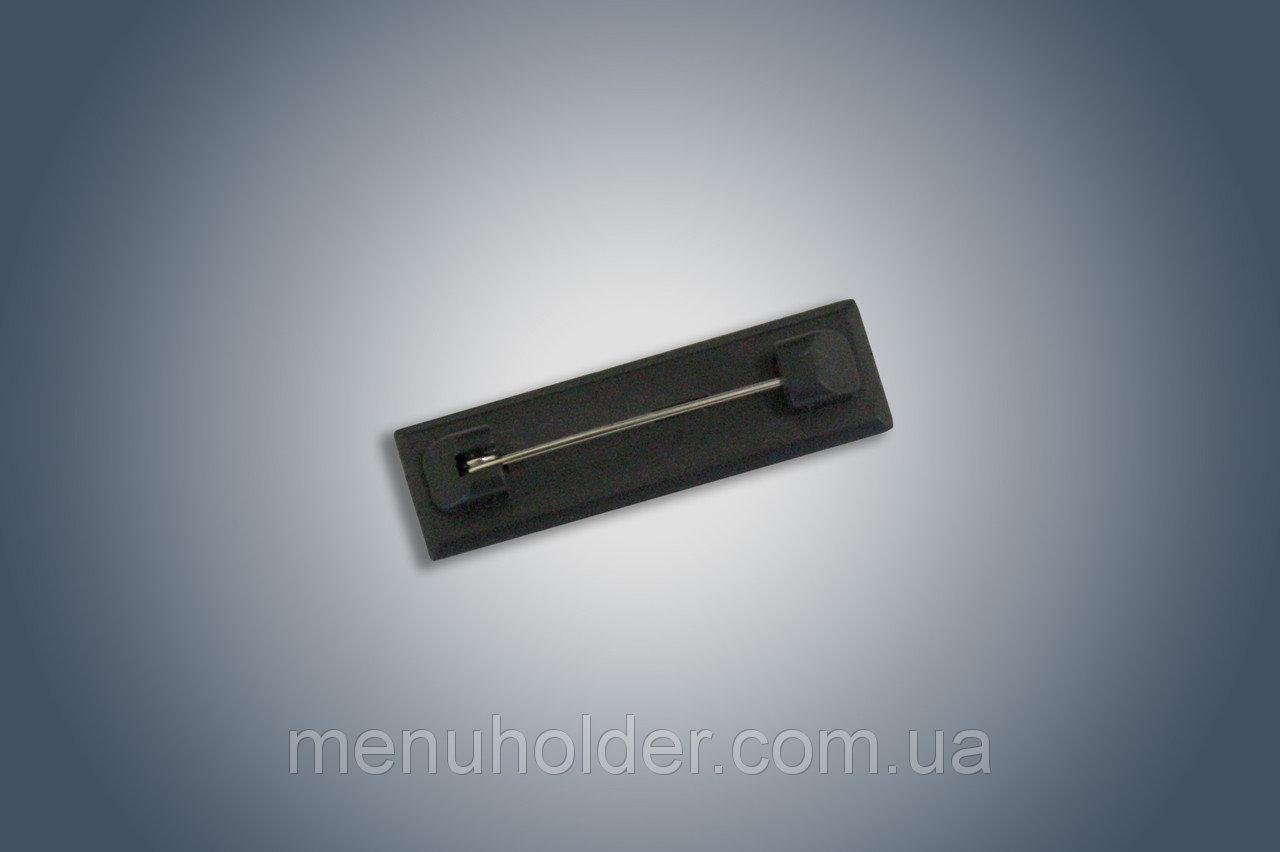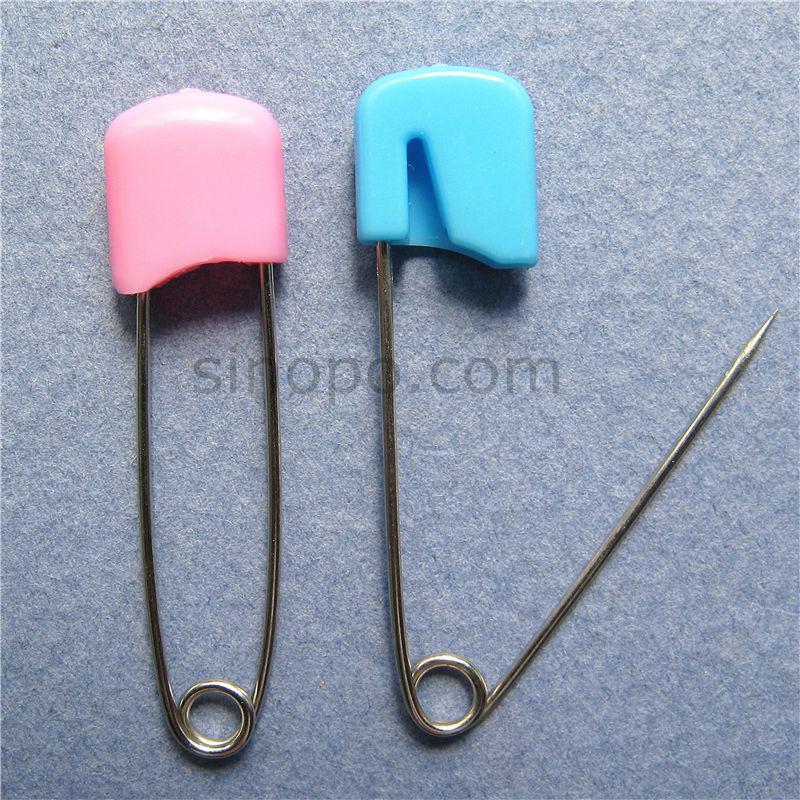The first image is the image on the left, the second image is the image on the right. Assess this claim about the two images: "One image shows only two safety pins, one pink and one blue.". Correct or not? Answer yes or no. Yes. 